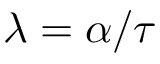Convert formula to latex. <formula><loc_0><loc_0><loc_500><loc_500>\lambda = \alpha / \tau</formula> 